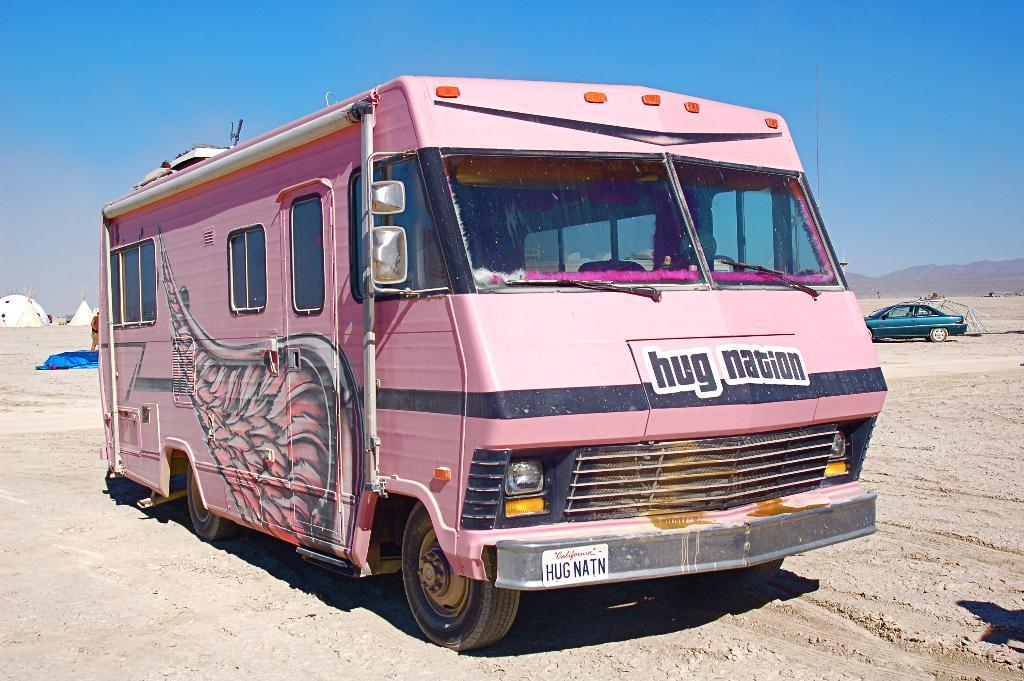What is the color of the caravan in the image? The caravan in the image is pink. Where is the car located in the image? The car is on the sand in the image. Can you describe the background of the image? In the background of the image, there is a person, tents, hills, and the sky. What type of wool is being spun in the cave in the image? There is no cave or wool present in the image. What discovery was made by the person in the background of the image? The image does not provide any information about a discovery made by the person in the background. 